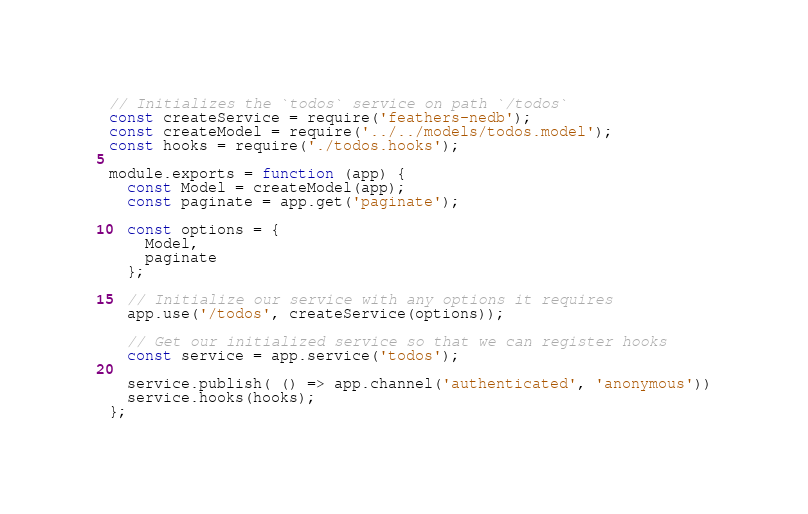<code> <loc_0><loc_0><loc_500><loc_500><_JavaScript_>// Initializes the `todos` service on path `/todos`
const createService = require('feathers-nedb');
const createModel = require('../../models/todos.model');
const hooks = require('./todos.hooks');

module.exports = function (app) {
  const Model = createModel(app);
  const paginate = app.get('paginate');

  const options = {
    Model,
    paginate
  };

  // Initialize our service with any options it requires
  app.use('/todos', createService(options));

  // Get our initialized service so that we can register hooks
  const service = app.service('todos');

  service.publish( () => app.channel('authenticated', 'anonymous'))
  service.hooks(hooks);
};
</code> 